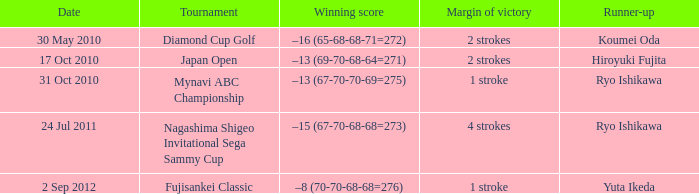Who was the runner-up in the japan open? Hiroyuki Fujita. 